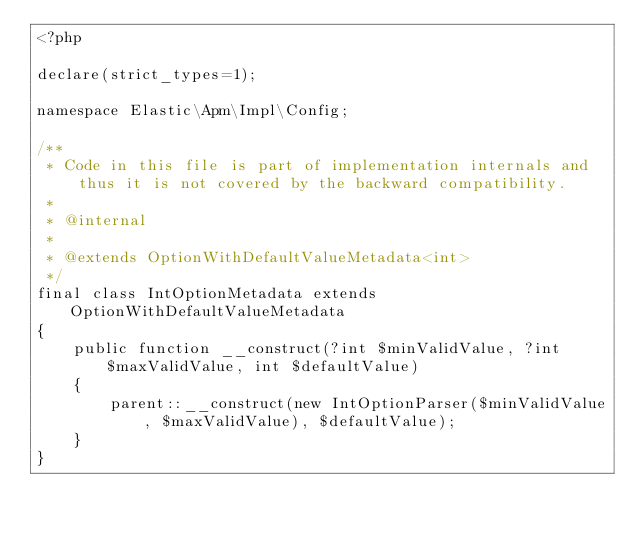Convert code to text. <code><loc_0><loc_0><loc_500><loc_500><_PHP_><?php

declare(strict_types=1);

namespace Elastic\Apm\Impl\Config;

/**
 * Code in this file is part of implementation internals and thus it is not covered by the backward compatibility.
 *
 * @internal
 *
 * @extends OptionWithDefaultValueMetadata<int>
 */
final class IntOptionMetadata extends OptionWithDefaultValueMetadata
{
    public function __construct(?int $minValidValue, ?int $maxValidValue, int $defaultValue)
    {
        parent::__construct(new IntOptionParser($minValidValue, $maxValidValue), $defaultValue);
    }
}
</code> 